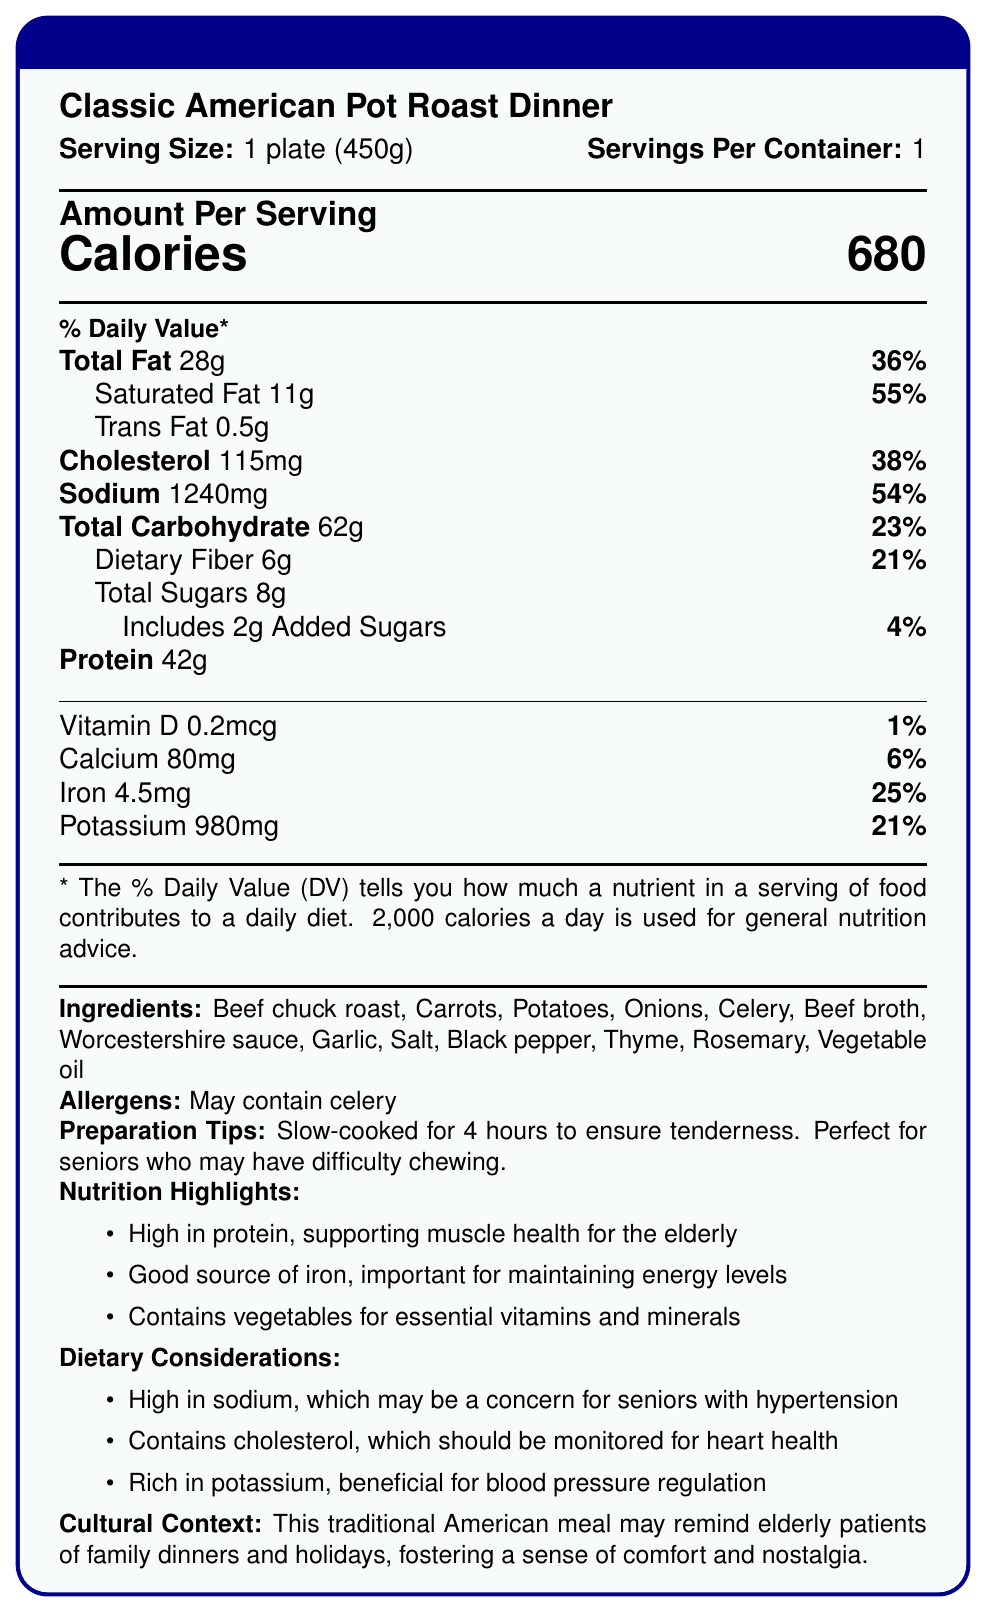what is the serving size for the Classic American Pot Roast Dinner? The serving size is clearly stated as 1 plate (450g) on the document.
Answer: 1 plate (450g) How many calories are there in one serving? The document shows the calories per serving as 680.
Answer: 680 What is the percentage of daily value for saturated fat in this meal? The percentage of daily value for saturated fat is listed as 55%.
Answer: 55% What is the amount of dietary fiber in one serving? The amount of dietary fiber is stated as 6g per serving.
Answer: 6g How much potassium does this meal contain? The document indicates that the meal contains 980mg of potassium.
Answer: 980mg What is the main ingredient in this meal? A. Potatoes B. Celery C. Beef chuck roast D. Carrots The main ingredient listed first is Beef chuck roast indicating it is the primary ingredient.
Answer: C Which nutrient is present in the highest amount by weight? A. Protein B. Total Carbohydrate C. Total Fat D. Dietary Fiber According to the document, Total Carbohydrate is 62g, which is the highest by weight compared to others listed.
Answer: B Is this meal high in sodium? The sodium content is 1240mg, which is 54% of the daily value, indicating it's high in sodium.
Answer: Yes Does this meal contain any allergens? The document notes that it may contain celery.
Answer: Yes Summarize the main nutritional benefits and considerations of this meal. The meal provides significant health benefits due to its protein and iron content, making it suitable for the elderly. It also contains vegetables that offer important nutrients. Despite these benefits, its high sodium and cholesterol content can be a concern for heart health and blood pressure.
Answer: The Classic American Pot Roast Dinner is high in protein and iron, beneficial for muscle health and maintaining energy levels in the elderly. It contains essential vitamins and minerals from vegetables. However, it is high in sodium and cholesterol, which should be monitored for heart health and hypertension. How is the preparation method of this meal indicated to be beneficial for seniors? The document states that the meal is slow-cooked for 4 hours to ensure tenderness, aiding seniors who may have difficulty chewing.
Answer: It is slow-cooked for 4 hours to ensure tenderness, making it perfect for seniors who may have difficulty chewing. What is the total fat content in this meal? Is it within the recommended daily value? The total fat content is 28g, and it is 36% of the daily value, which is within the recommended daily values based on a 2,000 calorie diet.
Answer: 28g, Yes What are the main dietary considerations mentioned for this meal? The dietary considerations pointed out are its high sodium and cholesterol content, which should be monitored, and its rich potassium content, beneficial for blood pressure regulation.
Answer: High in sodium and cholesterol, rich in potassium What percentage of daily value is provided by carbohydrates? The total carbohydrate content provides 23% of the daily value.
Answer: 23% What is the source of the culinary nostalgia mentioned in the cultural context? The document mentions that the traditional American nature of the meal, typical of family dinners and holidays, fosters a sense of comfort and nostalgia among the elderly.
Answer: This traditional American meal may remind elderly patients of family dinners and holidays, fostering a sense of comfort and nostalgia. What is the exact source of vitamin D in this meal? The document includes the amount of vitamin D but does not specify its source.
Answer: Not enough information 